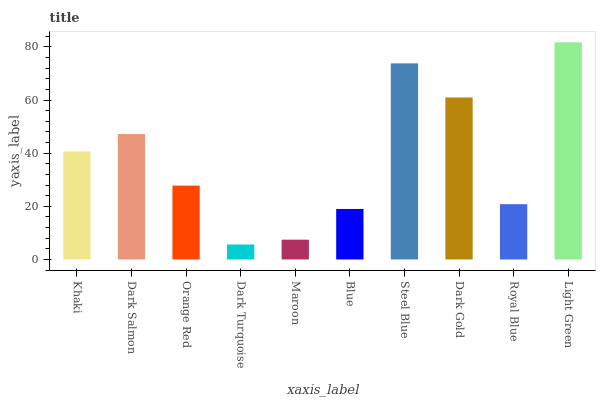Is Dark Turquoise the minimum?
Answer yes or no. Yes. Is Light Green the maximum?
Answer yes or no. Yes. Is Dark Salmon the minimum?
Answer yes or no. No. Is Dark Salmon the maximum?
Answer yes or no. No. Is Dark Salmon greater than Khaki?
Answer yes or no. Yes. Is Khaki less than Dark Salmon?
Answer yes or no. Yes. Is Khaki greater than Dark Salmon?
Answer yes or no. No. Is Dark Salmon less than Khaki?
Answer yes or no. No. Is Khaki the high median?
Answer yes or no. Yes. Is Orange Red the low median?
Answer yes or no. Yes. Is Dark Salmon the high median?
Answer yes or no. No. Is Dark Gold the low median?
Answer yes or no. No. 